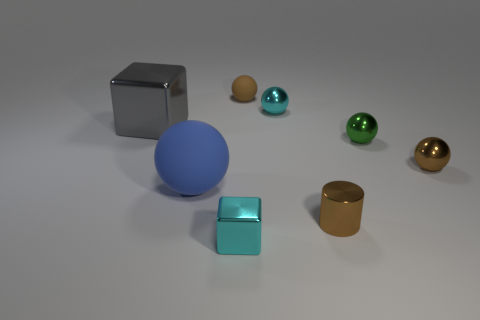Do the blue rubber ball and the shiny block that is behind the blue rubber sphere have the same size?
Offer a very short reply. Yes. There is a cyan metal object that is in front of the large gray thing; what shape is it?
Your answer should be compact. Cube. Are there any blue balls in front of the cyan shiny object in front of the tiny cyan metallic object behind the large cube?
Your answer should be very brief. No. What is the material of the big blue object that is the same shape as the small matte object?
Your response must be concise. Rubber. Is there any other thing that has the same material as the tiny brown cylinder?
Your answer should be very brief. Yes. What number of spheres are tiny green shiny things or large green things?
Your response must be concise. 1. Does the object that is on the left side of the big rubber ball have the same size as the cyan shiny object that is behind the big shiny block?
Provide a succinct answer. No. What is the cyan thing that is to the right of the small cyan thing that is in front of the big gray cube made of?
Ensure brevity in your answer.  Metal. Is the number of large blue balls left of the green shiny thing less than the number of big gray cubes?
Keep it short and to the point. No. There is a small green thing that is the same material as the tiny cylinder; what is its shape?
Offer a very short reply. Sphere. 